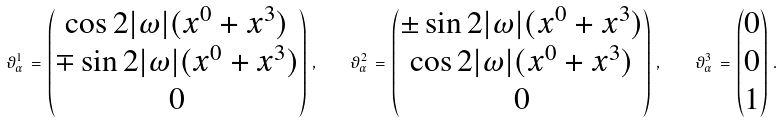<formula> <loc_0><loc_0><loc_500><loc_500>\vartheta ^ { 1 } _ { \alpha } \, = \, \begin{pmatrix} \cos 2 | \omega | ( x ^ { 0 } + x ^ { 3 } ) \\ \mp \sin 2 | \omega | ( x ^ { 0 } + x ^ { 3 } ) \\ 0 \end{pmatrix} \, , \quad \vartheta ^ { 2 } _ { \alpha } \, = \, \begin{pmatrix} \pm \sin 2 | \omega | ( x ^ { 0 } + x ^ { 3 } ) \\ \cos 2 | \omega | ( x ^ { 0 } + x ^ { 3 } ) \\ 0 \end{pmatrix} \, , \quad \vartheta ^ { 3 } _ { \alpha } \, = \, \begin{pmatrix} 0 \\ 0 \\ 1 \end{pmatrix} \, .</formula> 